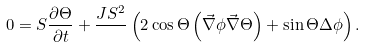<formula> <loc_0><loc_0><loc_500><loc_500>0 = S \frac { \partial \Theta } { \partial t } + \frac { J S ^ { 2 } } { } \left ( 2 \cos \Theta \left ( \vec { \nabla } \phi \vec { \nabla } \Theta \right ) + \sin \Theta \Delta \phi \right ) .</formula> 